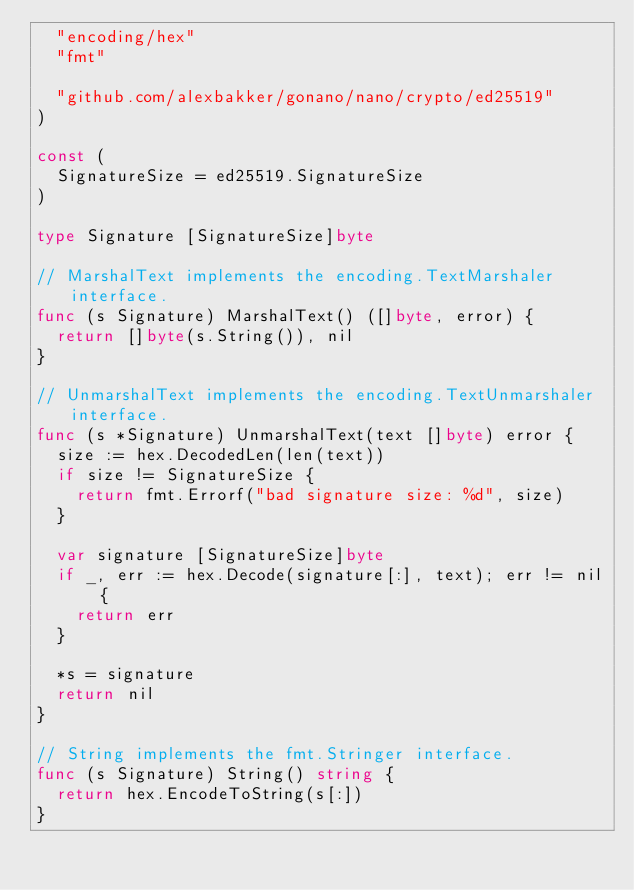<code> <loc_0><loc_0><loc_500><loc_500><_Go_>	"encoding/hex"
	"fmt"

	"github.com/alexbakker/gonano/nano/crypto/ed25519"
)

const (
	SignatureSize = ed25519.SignatureSize
)

type Signature [SignatureSize]byte

// MarshalText implements the encoding.TextMarshaler interface.
func (s Signature) MarshalText() ([]byte, error) {
	return []byte(s.String()), nil
}

// UnmarshalText implements the encoding.TextUnmarshaler interface.
func (s *Signature) UnmarshalText(text []byte) error {
	size := hex.DecodedLen(len(text))
	if size != SignatureSize {
		return fmt.Errorf("bad signature size: %d", size)
	}

	var signature [SignatureSize]byte
	if _, err := hex.Decode(signature[:], text); err != nil {
		return err
	}

	*s = signature
	return nil
}

// String implements the fmt.Stringer interface.
func (s Signature) String() string {
	return hex.EncodeToString(s[:])
}
</code> 